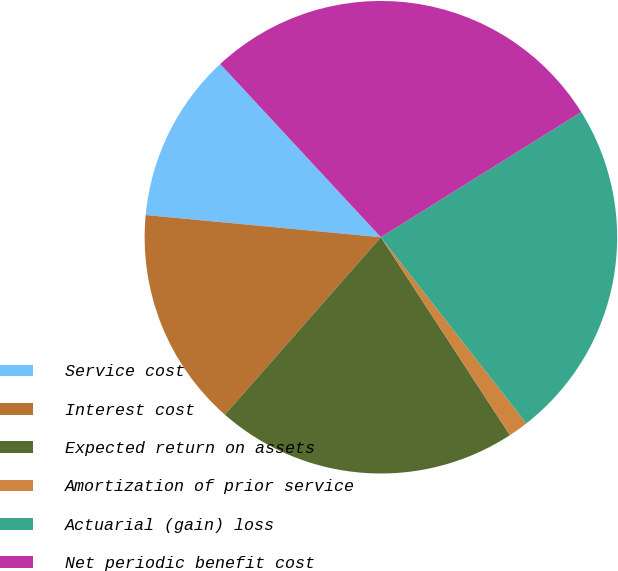Convert chart to OTSL. <chart><loc_0><loc_0><loc_500><loc_500><pie_chart><fcel>Service cost<fcel>Interest cost<fcel>Expected return on assets<fcel>Amortization of prior service<fcel>Actuarial (gain) loss<fcel>Net periodic benefit cost<nl><fcel>11.6%<fcel>15.02%<fcel>20.67%<fcel>1.36%<fcel>23.33%<fcel>28.01%<nl></chart> 